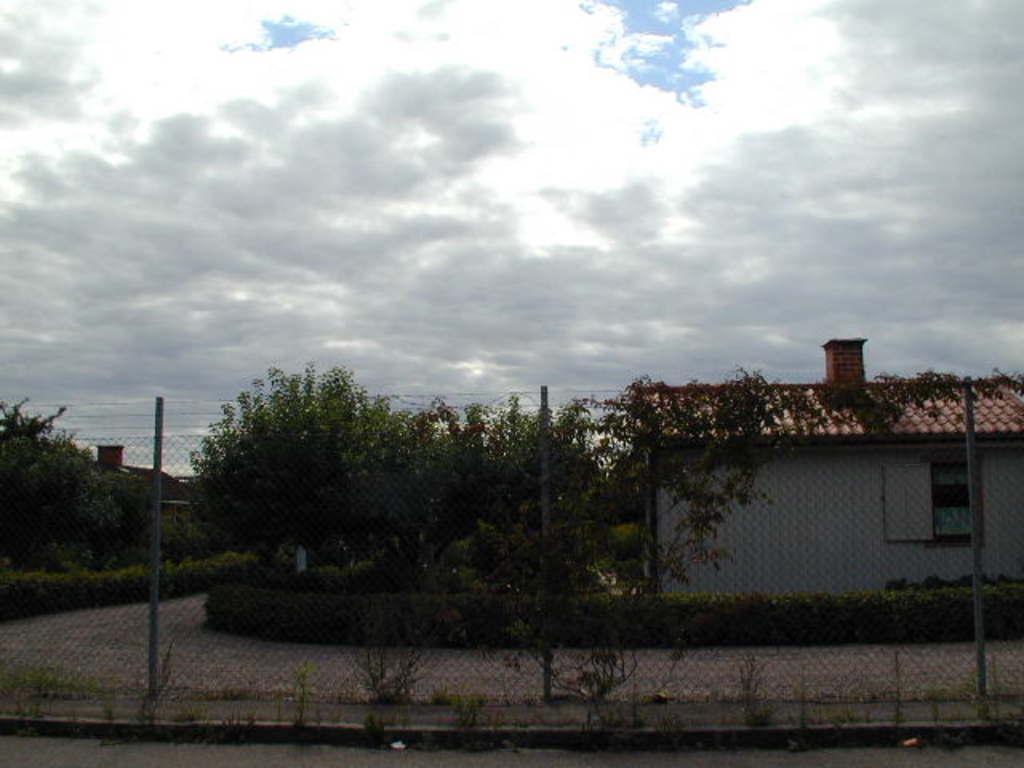In one or two sentences, can you explain what this image depicts? In the foreground of the picture there are plants and fencing. In the center of the picture there are trees, road and houses. At the top it is sky, sky is cloudy. 